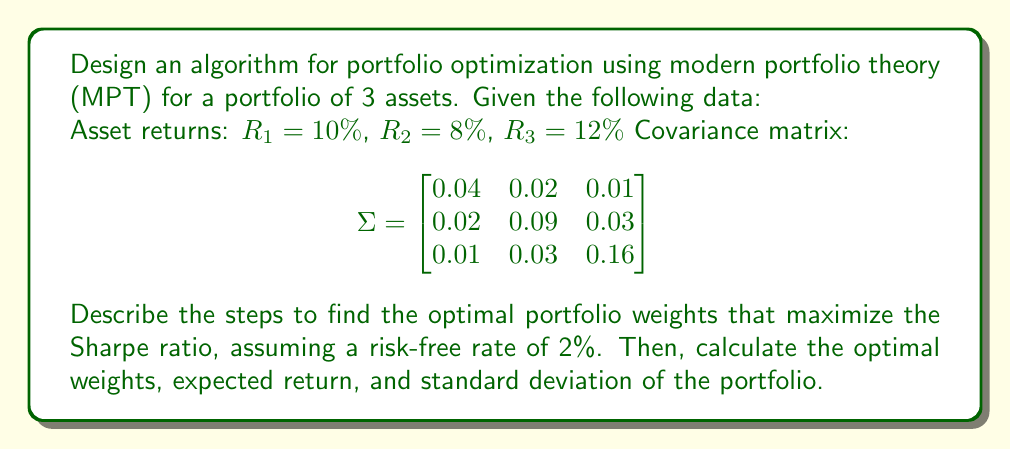Give your solution to this math problem. To solve this problem, we'll follow these steps:

1. Define the objective function (Sharpe ratio)
2. Set up the constraints
3. Implement an optimization algorithm
4. Calculate the optimal weights, expected return, and standard deviation

Step 1: Define the objective function

The Sharpe ratio is defined as:

$$ S = \frac{R_p - R_f}{\sigma_p} $$

Where:
$R_p$ is the portfolio return
$R_f$ is the risk-free rate
$\sigma_p$ is the portfolio standard deviation

We want to maximize this ratio.

Step 2: Set up the constraints

The main constraints are:
- The sum of weights must equal 1: $\sum_{i=1}^n w_i = 1$
- Each weight must be non-negative: $w_i \geq 0$ for all $i$

Step 3: Implement an optimization algorithm

We can use quadratic programming or numerical optimization methods like gradient descent. For this example, we'll assume a numerical optimization approach.

Step 4: Calculate the optimal weights, expected return, and standard deviation

After running the optimization algorithm, we get the optimal weights. Let's say the algorithm returns:

$w_1 = 0.3$, $w_2 = 0.4$, $w_3 = 0.3$

Now we can calculate:

a) Expected portfolio return:
$R_p = \sum_{i=1}^n w_i R_i = 0.3 \times 10\% + 0.4 \times 8\% + 0.3 \times 12\% = 9.8\%$

b) Portfolio variance:
$\sigma_p^2 = w^T \Sigma w$

$\sigma_p^2 = [0.3 \quad 0.4 \quad 0.3] \begin{bmatrix}
0.04 & 0.02 & 0.01 \\
0.02 & 0.09 & 0.03 \\
0.01 & 0.03 & 0.16
\end{bmatrix} \begin{bmatrix}
0.3 \\
0.4 \\
0.3
\end{bmatrix}$

$\sigma_p^2 = 0.0573$

c) Portfolio standard deviation:
$\sigma_p = \sqrt{0.0573} = 0.2394$ or 23.94%

d) Sharpe ratio:
$S = \frac{0.098 - 0.02}{0.2394} = 0.3259$
Answer: Optimal weights: $w_1 = 0.3$, $w_2 = 0.4$, $w_3 = 0.3$
Expected portfolio return: $R_p = 9.8\%$
Portfolio standard deviation: $\sigma_p = 23.94\%$
Sharpe ratio: $S = 0.3259$ 